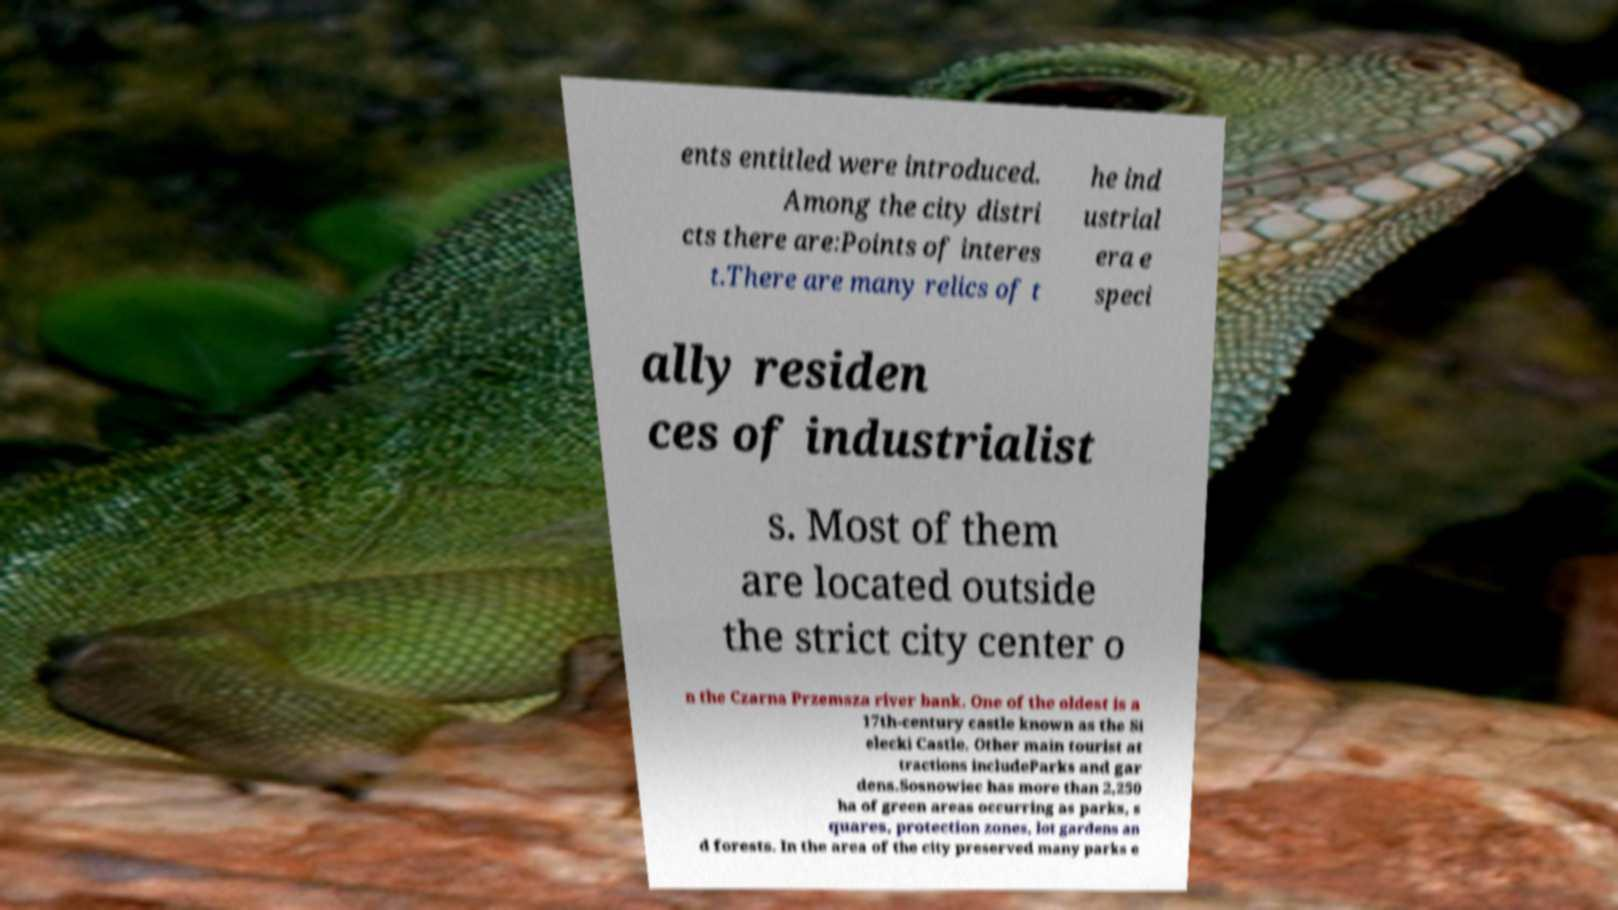Can you read and provide the text displayed in the image?This photo seems to have some interesting text. Can you extract and type it out for me? ents entitled were introduced. Among the city distri cts there are:Points of interes t.There are many relics of t he ind ustrial era e speci ally residen ces of industrialist s. Most of them are located outside the strict city center o n the Czarna Przemsza river bank. One of the oldest is a 17th-century castle known as the Si elecki Castle. Other main tourist at tractions includeParks and gar dens.Sosnowiec has more than 2,250 ha of green areas occurring as parks, s quares, protection zones, lot gardens an d forests. In the area of the city preserved many parks e 